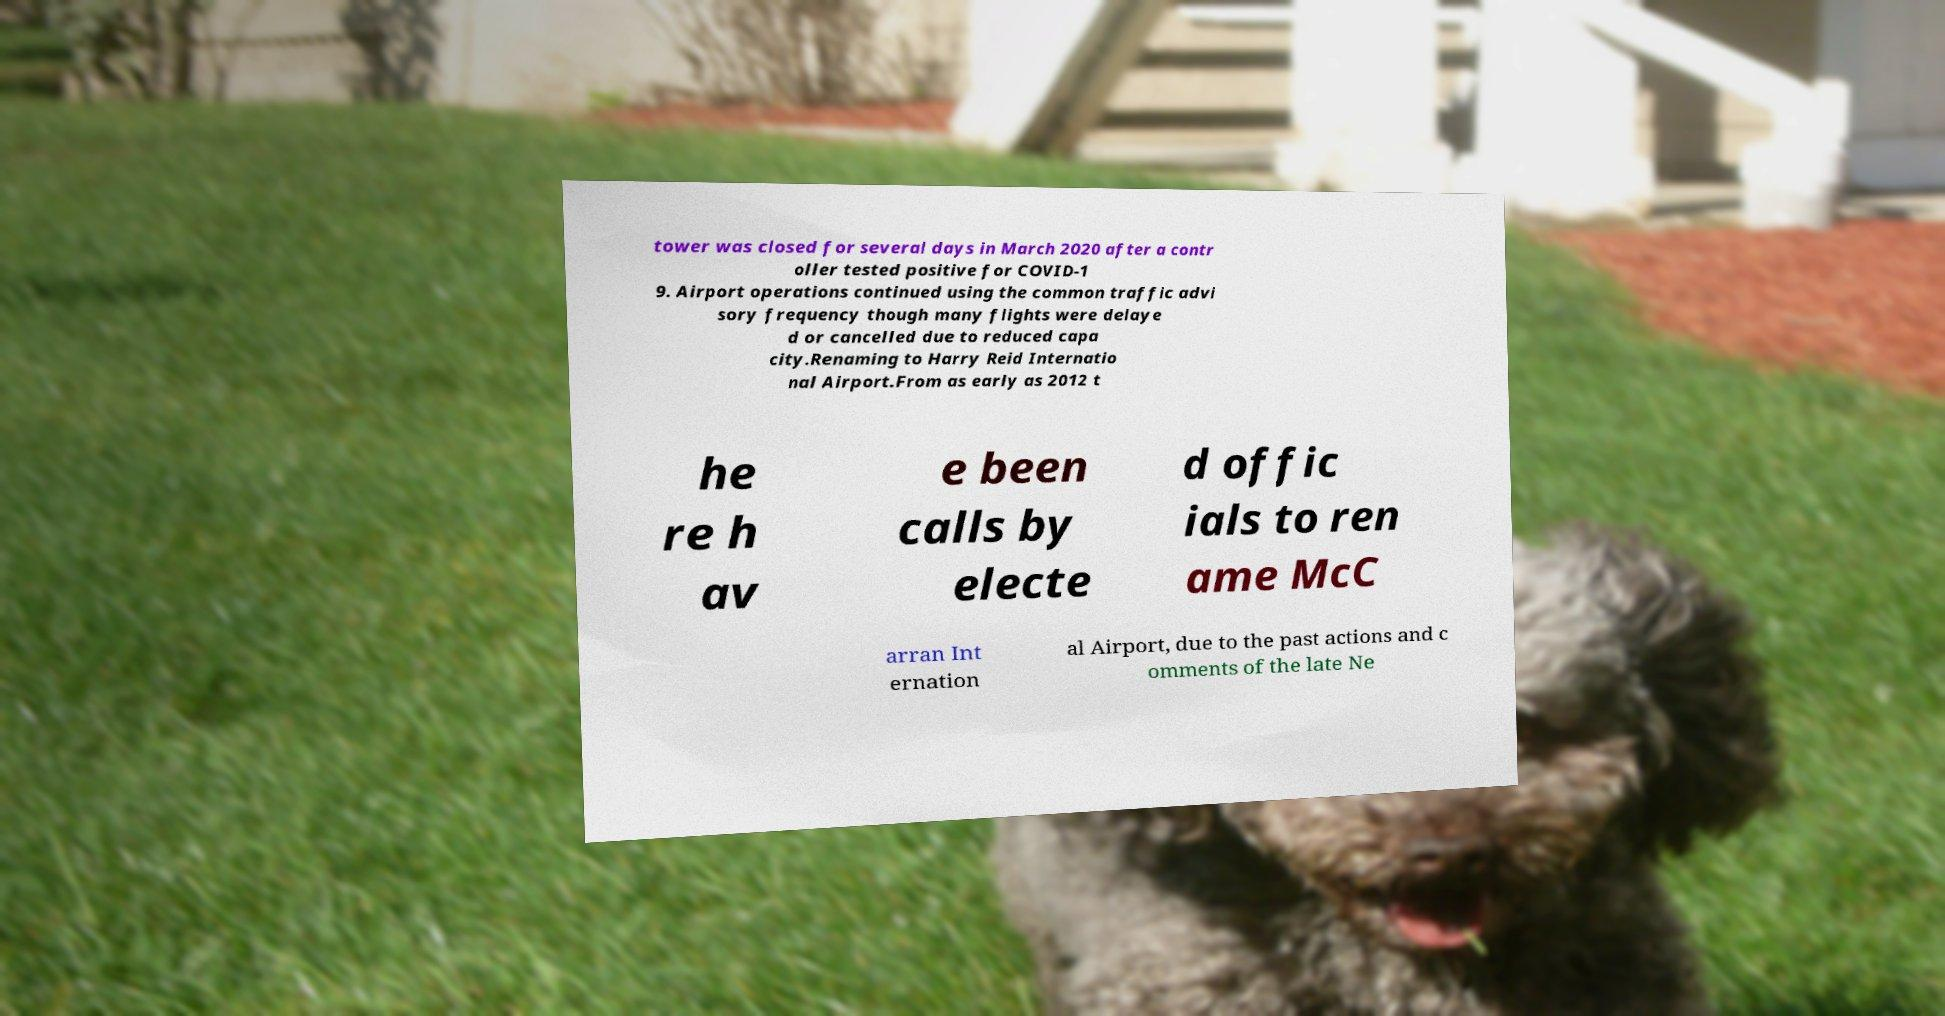Can you read and provide the text displayed in the image?This photo seems to have some interesting text. Can you extract and type it out for me? tower was closed for several days in March 2020 after a contr oller tested positive for COVID-1 9. Airport operations continued using the common traffic advi sory frequency though many flights were delaye d or cancelled due to reduced capa city.Renaming to Harry Reid Internatio nal Airport.From as early as 2012 t he re h av e been calls by electe d offic ials to ren ame McC arran Int ernation al Airport, due to the past actions and c omments of the late Ne 